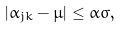<formula> <loc_0><loc_0><loc_500><loc_500>| \alpha _ { j k } - \mu | \leq \alpha \sigma ,</formula> 